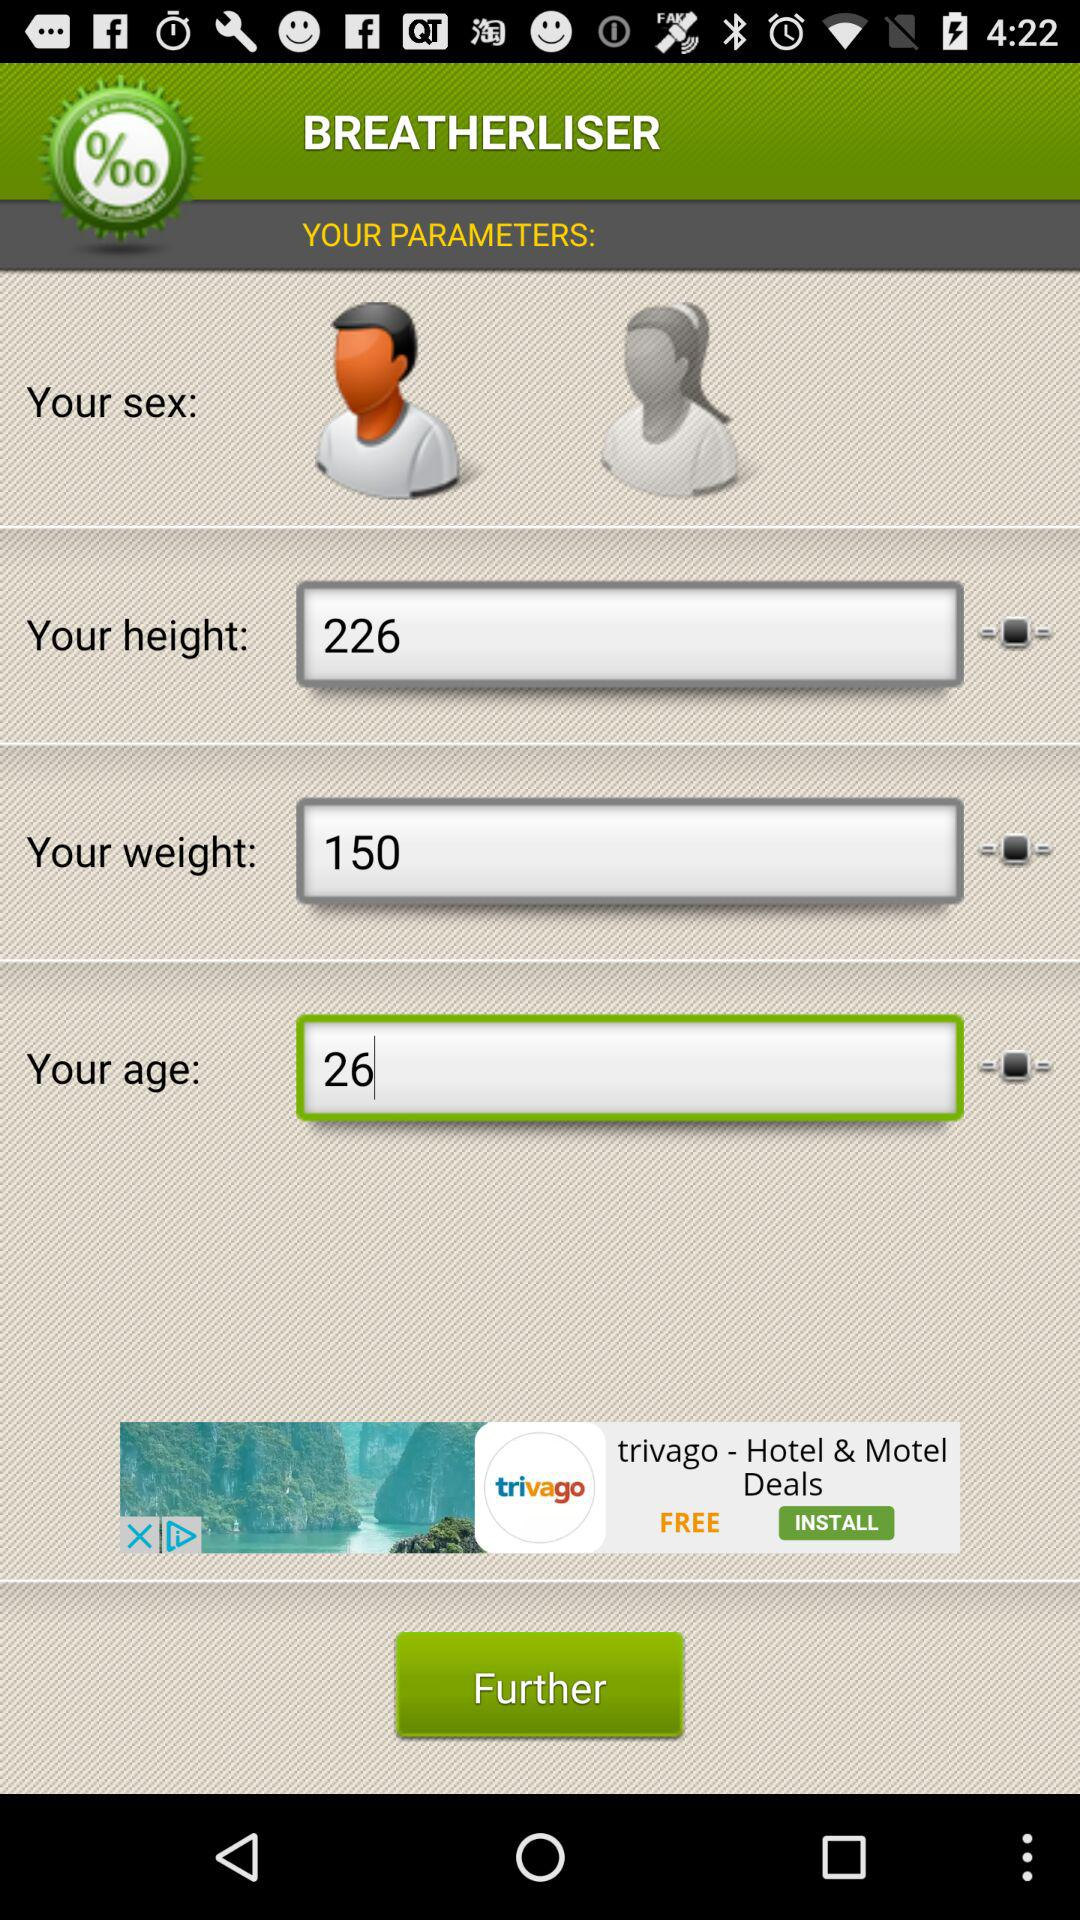What is the age? The age is 26. 